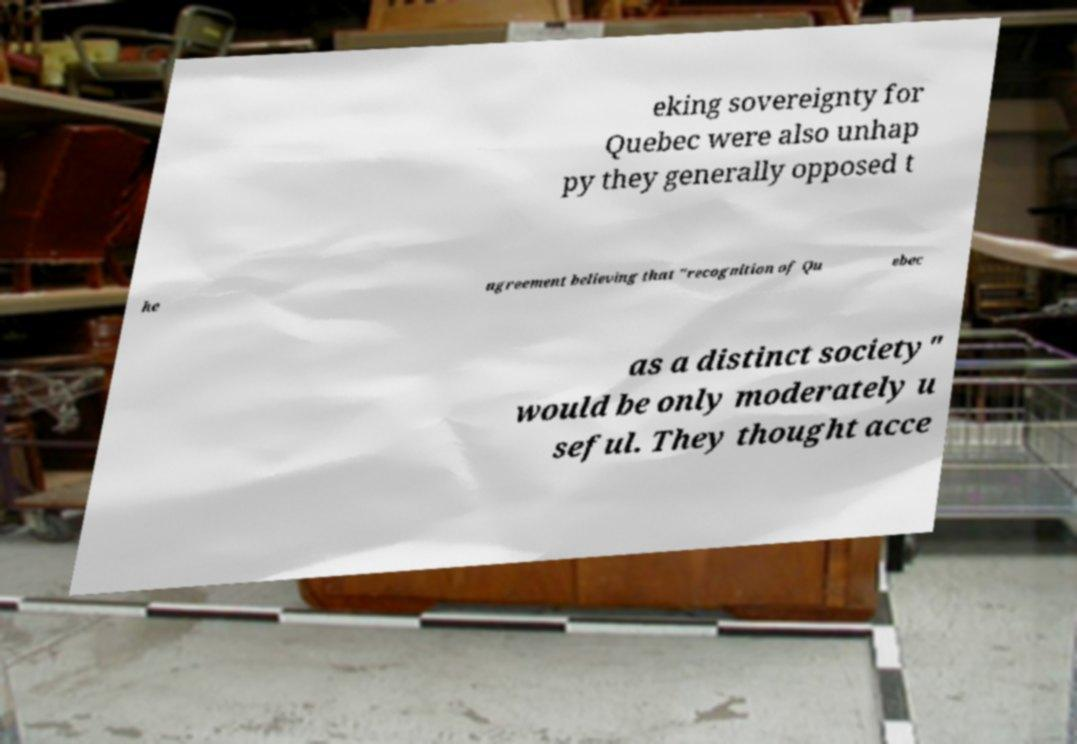Could you extract and type out the text from this image? eking sovereignty for Quebec were also unhap py they generally opposed t he agreement believing that "recognition of Qu ebec as a distinct society" would be only moderately u seful. They thought acce 